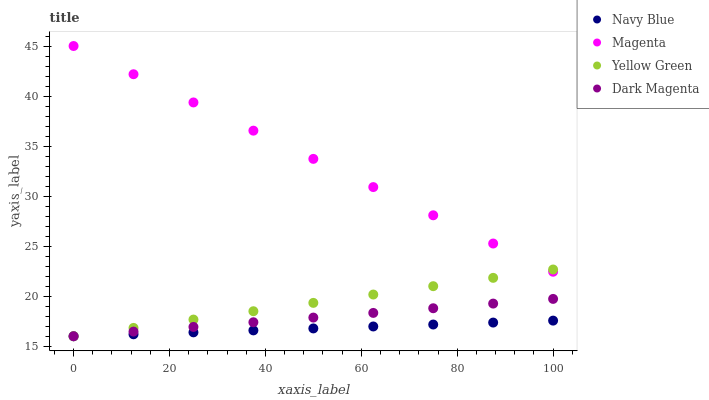Does Navy Blue have the minimum area under the curve?
Answer yes or no. Yes. Does Magenta have the maximum area under the curve?
Answer yes or no. Yes. Does Yellow Green have the minimum area under the curve?
Answer yes or no. No. Does Yellow Green have the maximum area under the curve?
Answer yes or no. No. Is Navy Blue the smoothest?
Answer yes or no. Yes. Is Magenta the roughest?
Answer yes or no. Yes. Is Yellow Green the smoothest?
Answer yes or no. No. Is Yellow Green the roughest?
Answer yes or no. No. Does Navy Blue have the lowest value?
Answer yes or no. Yes. Does Magenta have the lowest value?
Answer yes or no. No. Does Magenta have the highest value?
Answer yes or no. Yes. Does Yellow Green have the highest value?
Answer yes or no. No. Is Dark Magenta less than Magenta?
Answer yes or no. Yes. Is Magenta greater than Dark Magenta?
Answer yes or no. Yes. Does Magenta intersect Yellow Green?
Answer yes or no. Yes. Is Magenta less than Yellow Green?
Answer yes or no. No. Is Magenta greater than Yellow Green?
Answer yes or no. No. Does Dark Magenta intersect Magenta?
Answer yes or no. No. 